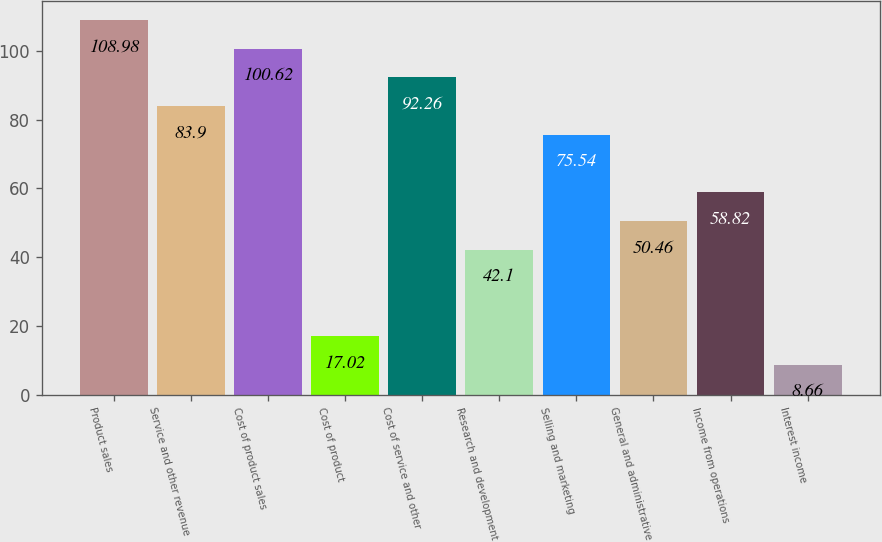<chart> <loc_0><loc_0><loc_500><loc_500><bar_chart><fcel>Product sales<fcel>Service and other revenue<fcel>Cost of product sales<fcel>Cost of product<fcel>Cost of service and other<fcel>Research and development<fcel>Selling and marketing<fcel>General and administrative<fcel>Income from operations<fcel>Interest income<nl><fcel>108.98<fcel>83.9<fcel>100.62<fcel>17.02<fcel>92.26<fcel>42.1<fcel>75.54<fcel>50.46<fcel>58.82<fcel>8.66<nl></chart> 